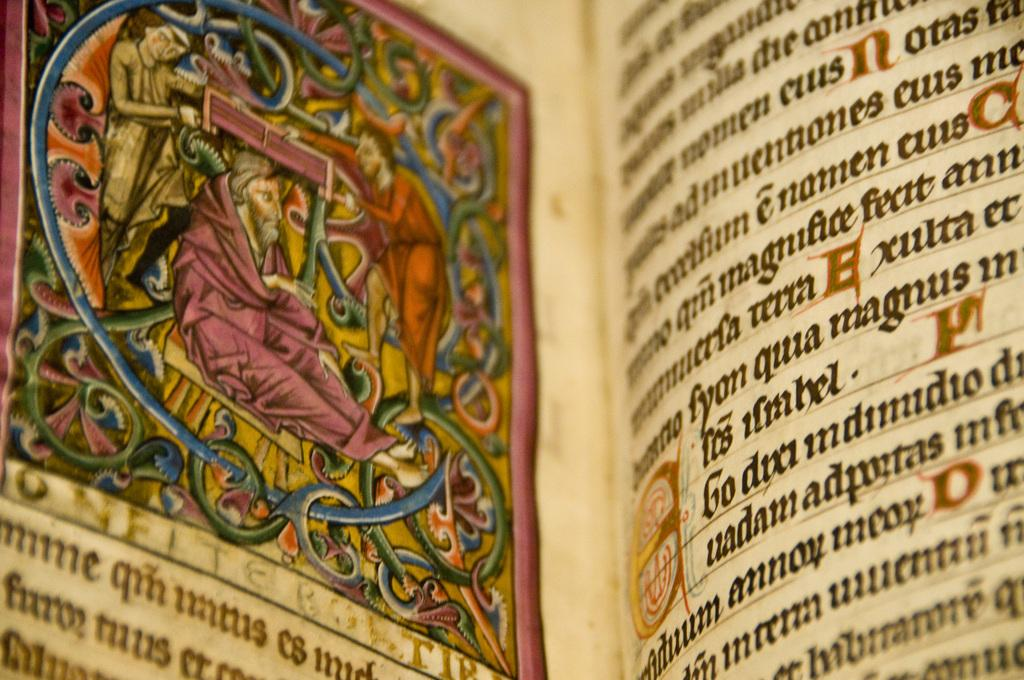<image>
Write a terse but informative summary of the picture. A book is open to a page that is written in a foreign language. 